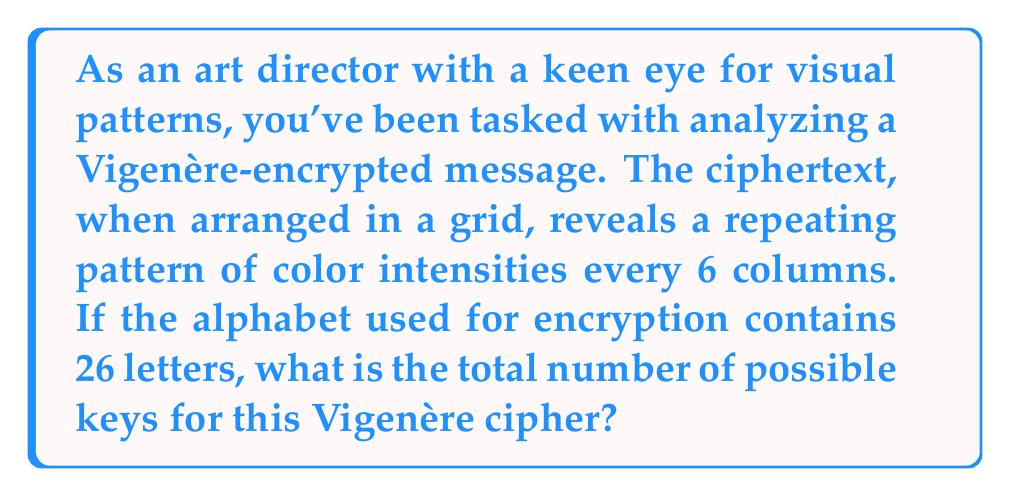Can you answer this question? Let's approach this step-by-step:

1) The repeating pattern every 6 columns suggests that the key length is 6 characters.

2) In a Vigenère cipher, each character of the key corresponds to a shift in the alphabet.

3) With an alphabet of 26 letters, each character in the key can be any of these 26 letters.

4) For each position in the key, we have 26 choices.

5) The key has 6 positions, and for each position, we have 26 independent choices.

6) This scenario corresponds to the multiplication principle in combinatorics.

7) The total number of possible keys is therefore:

   $$26 \times 26 \times 26 \times 26 \times 26 \times 26 = 26^6$$

8) We can calculate this:

   $$26^6 = 308,915,776$$

Therefore, there are 308,915,776 possible keys for this Vigenère cipher.
Answer: $26^6 = 308,915,776$ 